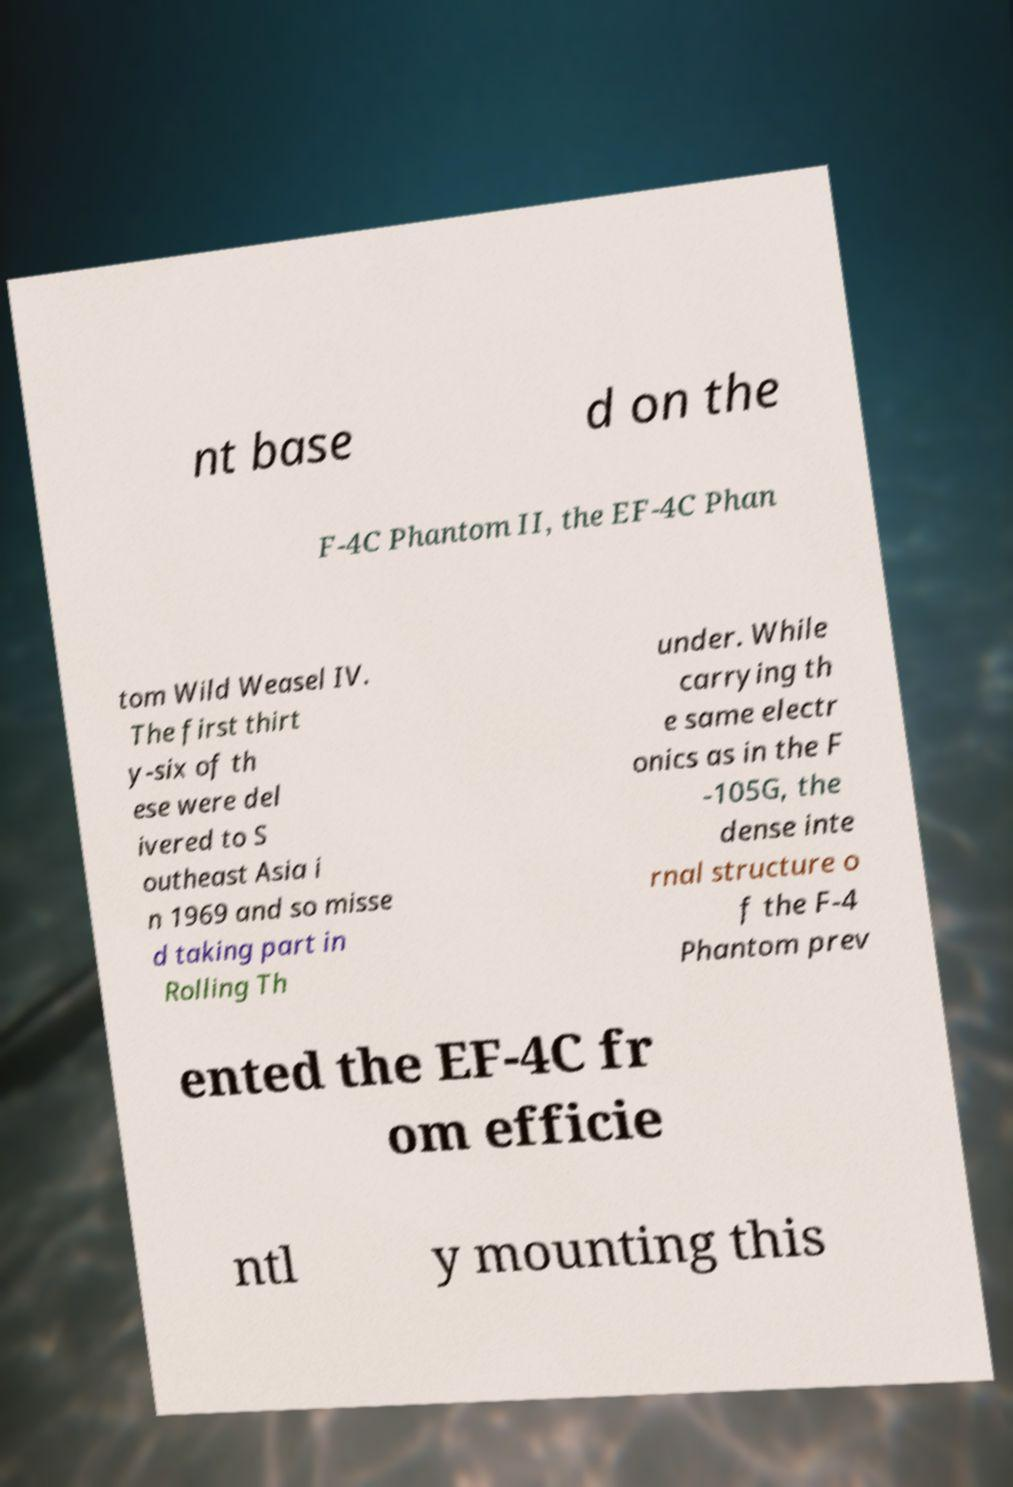Please read and relay the text visible in this image. What does it say? nt base d on the F-4C Phantom II, the EF-4C Phan tom Wild Weasel IV. The first thirt y-six of th ese were del ivered to S outheast Asia i n 1969 and so misse d taking part in Rolling Th under. While carrying th e same electr onics as in the F -105G, the dense inte rnal structure o f the F-4 Phantom prev ented the EF-4C fr om efficie ntl y mounting this 